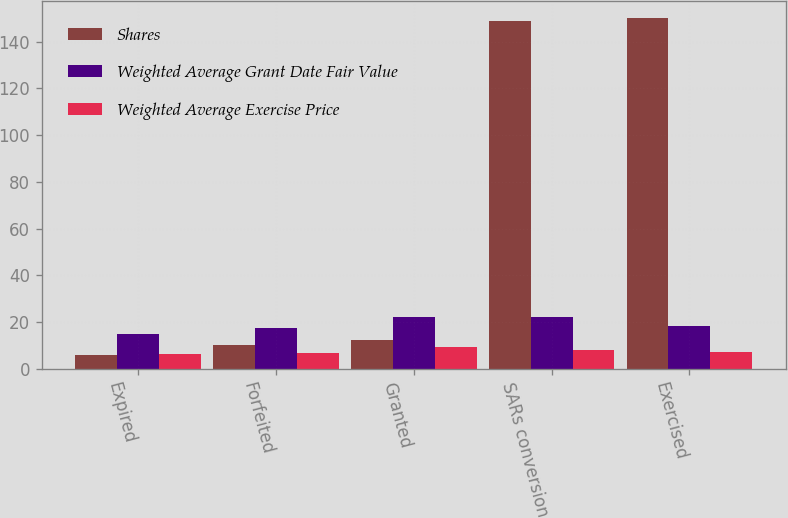Convert chart to OTSL. <chart><loc_0><loc_0><loc_500><loc_500><stacked_bar_chart><ecel><fcel>Expired<fcel>Forfeited<fcel>Granted<fcel>SARs conversion<fcel>Exercised<nl><fcel>Shares<fcel>6<fcel>10<fcel>12.485<fcel>149<fcel>150<nl><fcel>Weighted Average Grant Date Fair Value<fcel>14.97<fcel>17.49<fcel>22<fcel>22.35<fcel>18.33<nl><fcel>Weighted Average Exercise Price<fcel>6.27<fcel>6.81<fcel>9.21<fcel>8.08<fcel>7.24<nl></chart> 